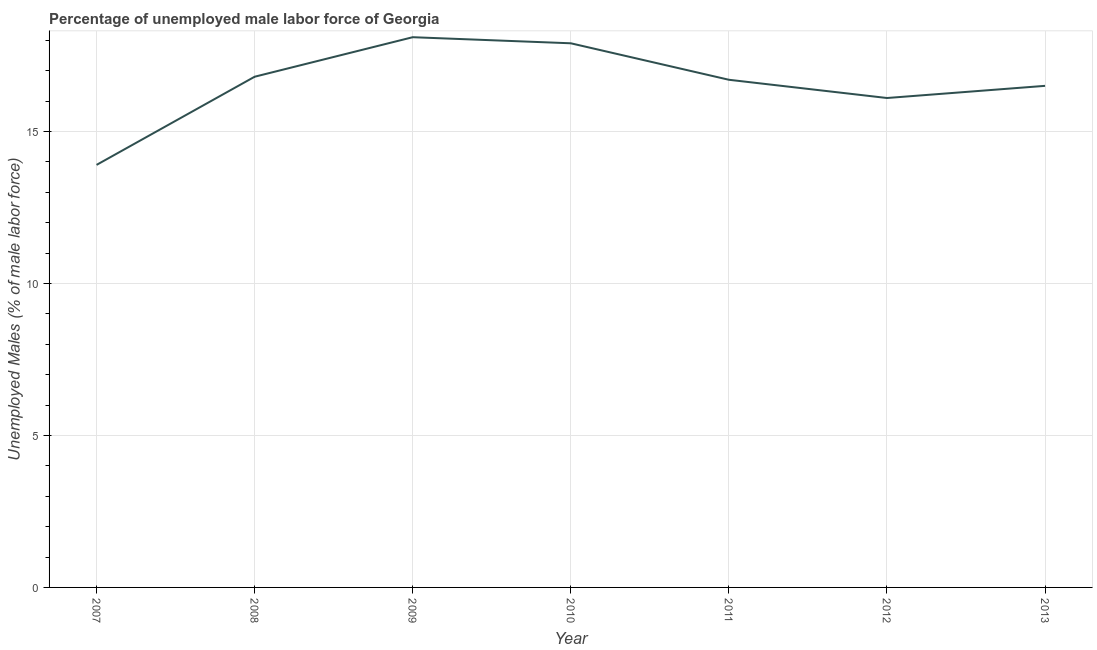Across all years, what is the maximum total unemployed male labour force?
Ensure brevity in your answer.  18.1. Across all years, what is the minimum total unemployed male labour force?
Offer a very short reply. 13.9. In which year was the total unemployed male labour force maximum?
Offer a very short reply. 2009. In which year was the total unemployed male labour force minimum?
Give a very brief answer. 2007. What is the sum of the total unemployed male labour force?
Provide a succinct answer. 116. What is the difference between the total unemployed male labour force in 2007 and 2012?
Give a very brief answer. -2.2. What is the average total unemployed male labour force per year?
Offer a terse response. 16.57. What is the median total unemployed male labour force?
Offer a very short reply. 16.7. In how many years, is the total unemployed male labour force greater than 1 %?
Give a very brief answer. 7. Do a majority of the years between 2012 and 2008 (inclusive) have total unemployed male labour force greater than 8 %?
Make the answer very short. Yes. What is the ratio of the total unemployed male labour force in 2007 to that in 2011?
Your response must be concise. 0.83. Is the total unemployed male labour force in 2008 less than that in 2010?
Your response must be concise. Yes. Is the difference between the total unemployed male labour force in 2007 and 2013 greater than the difference between any two years?
Your answer should be compact. No. What is the difference between the highest and the second highest total unemployed male labour force?
Offer a very short reply. 0.2. Is the sum of the total unemployed male labour force in 2009 and 2013 greater than the maximum total unemployed male labour force across all years?
Ensure brevity in your answer.  Yes. What is the difference between the highest and the lowest total unemployed male labour force?
Your answer should be compact. 4.2. Does the total unemployed male labour force monotonically increase over the years?
Your response must be concise. No. How many lines are there?
Give a very brief answer. 1. How many years are there in the graph?
Offer a terse response. 7. Are the values on the major ticks of Y-axis written in scientific E-notation?
Give a very brief answer. No. Does the graph contain any zero values?
Provide a short and direct response. No. What is the title of the graph?
Make the answer very short. Percentage of unemployed male labor force of Georgia. What is the label or title of the X-axis?
Offer a very short reply. Year. What is the label or title of the Y-axis?
Give a very brief answer. Unemployed Males (% of male labor force). What is the Unemployed Males (% of male labor force) in 2007?
Offer a terse response. 13.9. What is the Unemployed Males (% of male labor force) in 2008?
Keep it short and to the point. 16.8. What is the Unemployed Males (% of male labor force) in 2009?
Ensure brevity in your answer.  18.1. What is the Unemployed Males (% of male labor force) in 2010?
Provide a short and direct response. 17.9. What is the Unemployed Males (% of male labor force) of 2011?
Offer a very short reply. 16.7. What is the Unemployed Males (% of male labor force) in 2012?
Your answer should be very brief. 16.1. What is the difference between the Unemployed Males (% of male labor force) in 2007 and 2009?
Offer a terse response. -4.2. What is the difference between the Unemployed Males (% of male labor force) in 2007 and 2010?
Ensure brevity in your answer.  -4. What is the difference between the Unemployed Males (% of male labor force) in 2007 and 2012?
Make the answer very short. -2.2. What is the difference between the Unemployed Males (% of male labor force) in 2007 and 2013?
Your response must be concise. -2.6. What is the difference between the Unemployed Males (% of male labor force) in 2008 and 2011?
Provide a short and direct response. 0.1. What is the difference between the Unemployed Males (% of male labor force) in 2008 and 2012?
Give a very brief answer. 0.7. What is the difference between the Unemployed Males (% of male labor force) in 2009 and 2012?
Keep it short and to the point. 2. What is the difference between the Unemployed Males (% of male labor force) in 2009 and 2013?
Your answer should be very brief. 1.6. What is the difference between the Unemployed Males (% of male labor force) in 2011 and 2012?
Your response must be concise. 0.6. What is the difference between the Unemployed Males (% of male labor force) in 2011 and 2013?
Provide a succinct answer. 0.2. What is the ratio of the Unemployed Males (% of male labor force) in 2007 to that in 2008?
Your response must be concise. 0.83. What is the ratio of the Unemployed Males (% of male labor force) in 2007 to that in 2009?
Offer a terse response. 0.77. What is the ratio of the Unemployed Males (% of male labor force) in 2007 to that in 2010?
Offer a terse response. 0.78. What is the ratio of the Unemployed Males (% of male labor force) in 2007 to that in 2011?
Offer a very short reply. 0.83. What is the ratio of the Unemployed Males (% of male labor force) in 2007 to that in 2012?
Ensure brevity in your answer.  0.86. What is the ratio of the Unemployed Males (% of male labor force) in 2007 to that in 2013?
Your answer should be very brief. 0.84. What is the ratio of the Unemployed Males (% of male labor force) in 2008 to that in 2009?
Keep it short and to the point. 0.93. What is the ratio of the Unemployed Males (% of male labor force) in 2008 to that in 2010?
Offer a very short reply. 0.94. What is the ratio of the Unemployed Males (% of male labor force) in 2008 to that in 2011?
Offer a terse response. 1.01. What is the ratio of the Unemployed Males (% of male labor force) in 2008 to that in 2012?
Provide a succinct answer. 1.04. What is the ratio of the Unemployed Males (% of male labor force) in 2008 to that in 2013?
Your answer should be compact. 1.02. What is the ratio of the Unemployed Males (% of male labor force) in 2009 to that in 2011?
Provide a short and direct response. 1.08. What is the ratio of the Unemployed Males (% of male labor force) in 2009 to that in 2012?
Provide a short and direct response. 1.12. What is the ratio of the Unemployed Males (% of male labor force) in 2009 to that in 2013?
Make the answer very short. 1.1. What is the ratio of the Unemployed Males (% of male labor force) in 2010 to that in 2011?
Offer a terse response. 1.07. What is the ratio of the Unemployed Males (% of male labor force) in 2010 to that in 2012?
Make the answer very short. 1.11. What is the ratio of the Unemployed Males (% of male labor force) in 2010 to that in 2013?
Ensure brevity in your answer.  1.08. What is the ratio of the Unemployed Males (% of male labor force) in 2012 to that in 2013?
Your response must be concise. 0.98. 